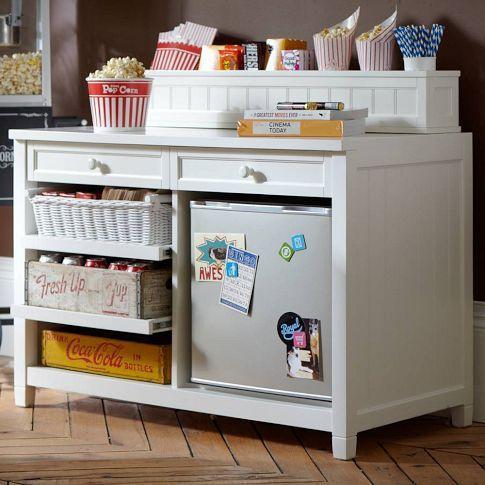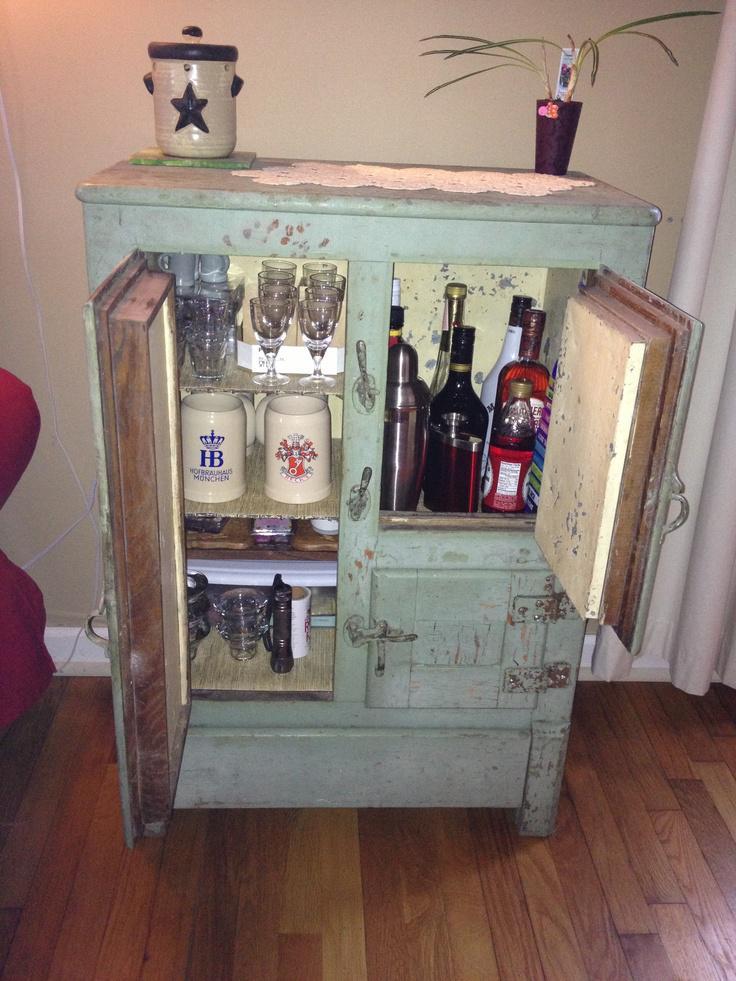The first image is the image on the left, the second image is the image on the right. For the images shown, is this caption "At least one wine bottle is being stored horizontally in a rack." true? Answer yes or no. No. The first image is the image on the left, the second image is the image on the right. Considering the images on both sides, is "In at least one image there is a brown chair next to a homemade bar." valid? Answer yes or no. No. 